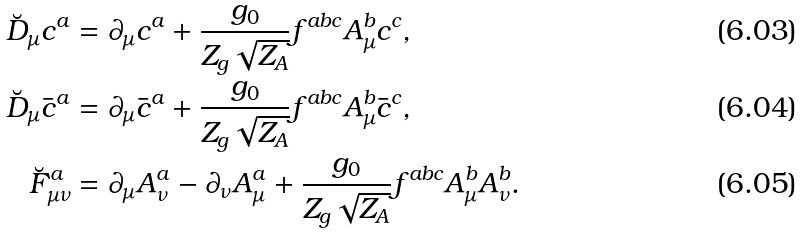<formula> <loc_0><loc_0><loc_500><loc_500>\breve { D } _ { \mu } c ^ { a } & = \partial _ { \mu } c ^ { a } + \frac { g _ { 0 } } { Z _ { g } \sqrt { Z _ { A } } } f ^ { a b c } A _ { \mu } ^ { b } c ^ { c } , \\ \breve { D } _ { \mu } \bar { c } ^ { a } & = \partial _ { \mu } \bar { c } ^ { a } + \frac { g _ { 0 } } { Z _ { g } \sqrt { Z _ { A } } } f ^ { a b c } A _ { \mu } ^ { b } \bar { c } ^ { c } , \\ \breve { F } ^ { a } _ { \mu \nu } & = \partial _ { \mu } A _ { \nu } ^ { a } - \partial _ { \nu } A _ { \mu } ^ { a } + \frac { g _ { 0 } } { Z _ { g } \sqrt { Z _ { A } } } f ^ { a b c } A _ { \mu } ^ { b } A _ { \nu } ^ { b } .</formula> 